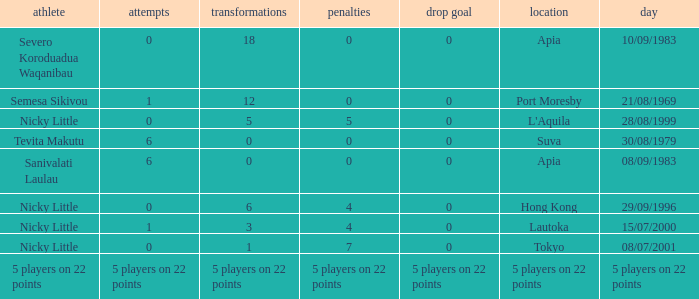How many drops did Nicky Little have in Hong Kong? 0.0. 